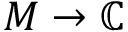Convert formula to latex. <formula><loc_0><loc_0><loc_500><loc_500>M \to \mathbb { C }</formula> 